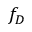<formula> <loc_0><loc_0><loc_500><loc_500>f _ { D }</formula> 